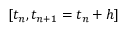<formula> <loc_0><loc_0><loc_500><loc_500>[ t _ { n } , t _ { n + 1 } = t _ { n } + h ]</formula> 